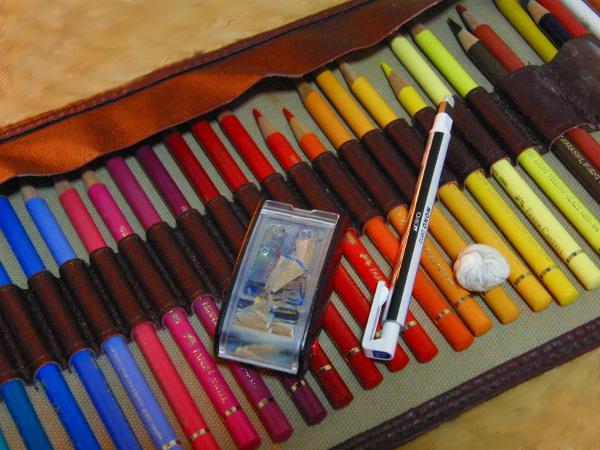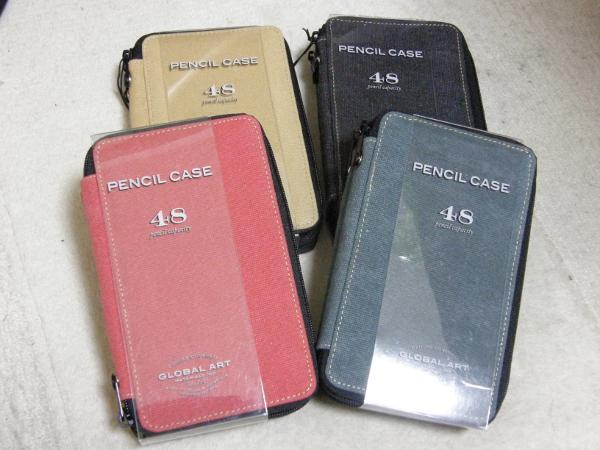The first image is the image on the left, the second image is the image on the right. Assess this claim about the two images: "Both images feature pencils strapped inside a case.". Correct or not? Answer yes or no. No. The first image is the image on the left, the second image is the image on the right. Assess this claim about the two images: "Each image includes colored pencils, and at least one image shows an open pencil case that has a long black strap running its length to secure the pencils.". Correct or not? Answer yes or no. No. 